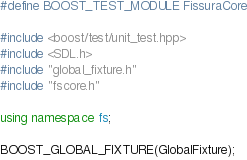Convert code to text. <code><loc_0><loc_0><loc_500><loc_500><_C++_>#define BOOST_TEST_MODULE FissuraCore

#include <boost/test/unit_test.hpp>
#include <SDL.h>
#include "global_fixture.h"
#include "fscore.h"

using namespace fs;

BOOST_GLOBAL_FIXTURE(GlobalFixture);
</code> 